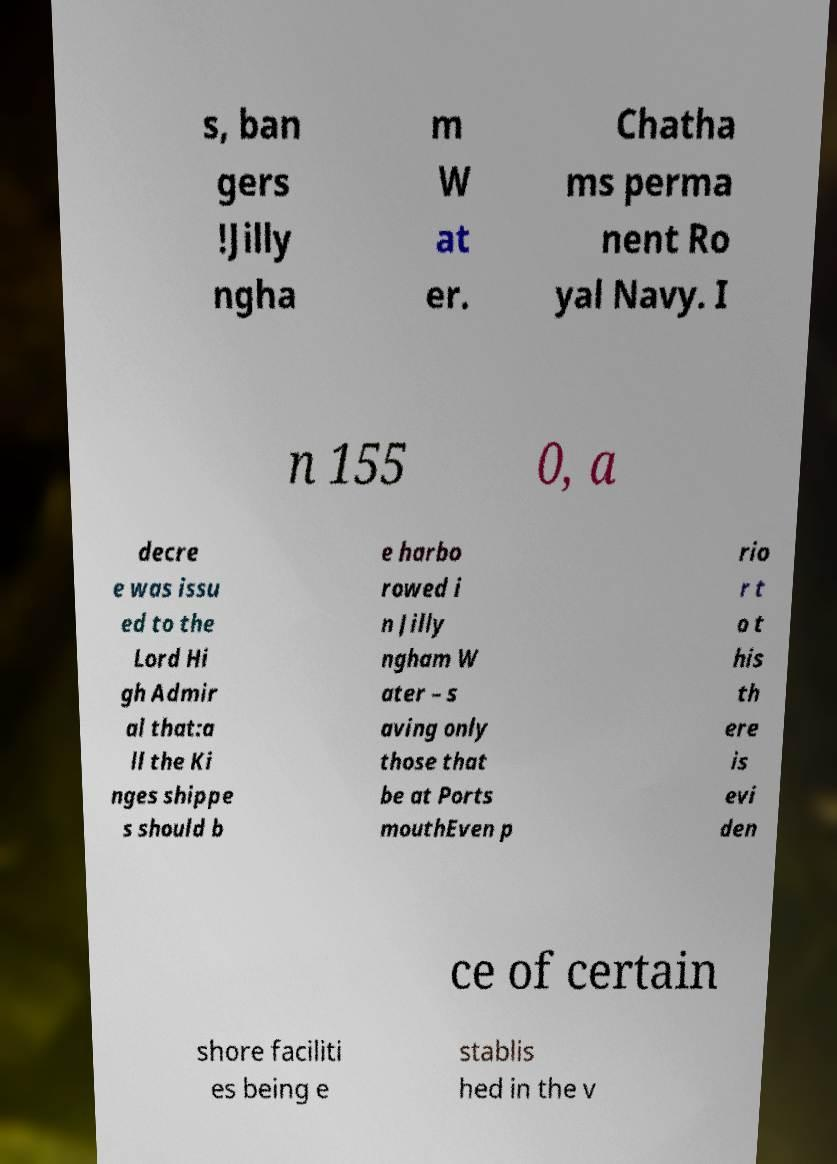Could you assist in decoding the text presented in this image and type it out clearly? s, ban gers !Jilly ngha m W at er. Chatha ms perma nent Ro yal Navy. I n 155 0, a decre e was issu ed to the Lord Hi gh Admir al that:a ll the Ki nges shippe s should b e harbo rowed i n Jilly ngham W ater – s aving only those that be at Ports mouthEven p rio r t o t his th ere is evi den ce of certain shore faciliti es being e stablis hed in the v 